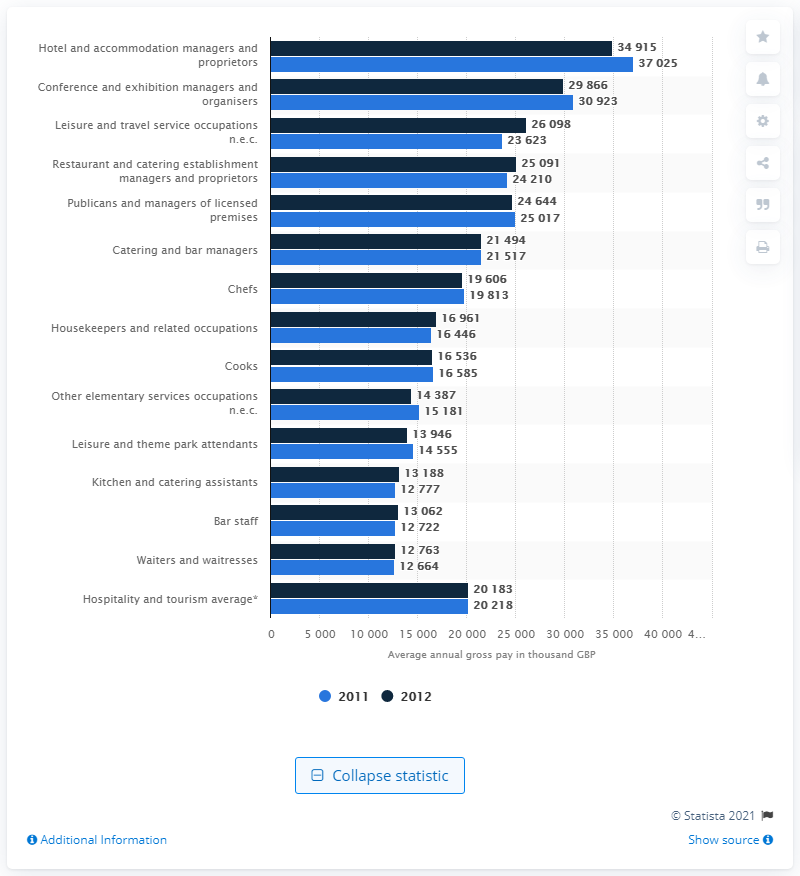Highlight a few significant elements in this photo. In 2012, the earnings of catering and bar managers were 21,517. 